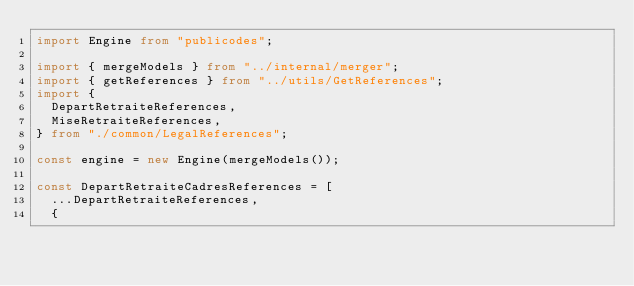Convert code to text. <code><loc_0><loc_0><loc_500><loc_500><_TypeScript_>import Engine from "publicodes";

import { mergeModels } from "../internal/merger";
import { getReferences } from "../utils/GetReferences";
import {
  DepartRetraiteReferences,
  MiseRetraiteReferences,
} from "./common/LegalReferences";

const engine = new Engine(mergeModels());

const DepartRetraiteCadresReferences = [
  ...DepartRetraiteReferences,
  {</code> 